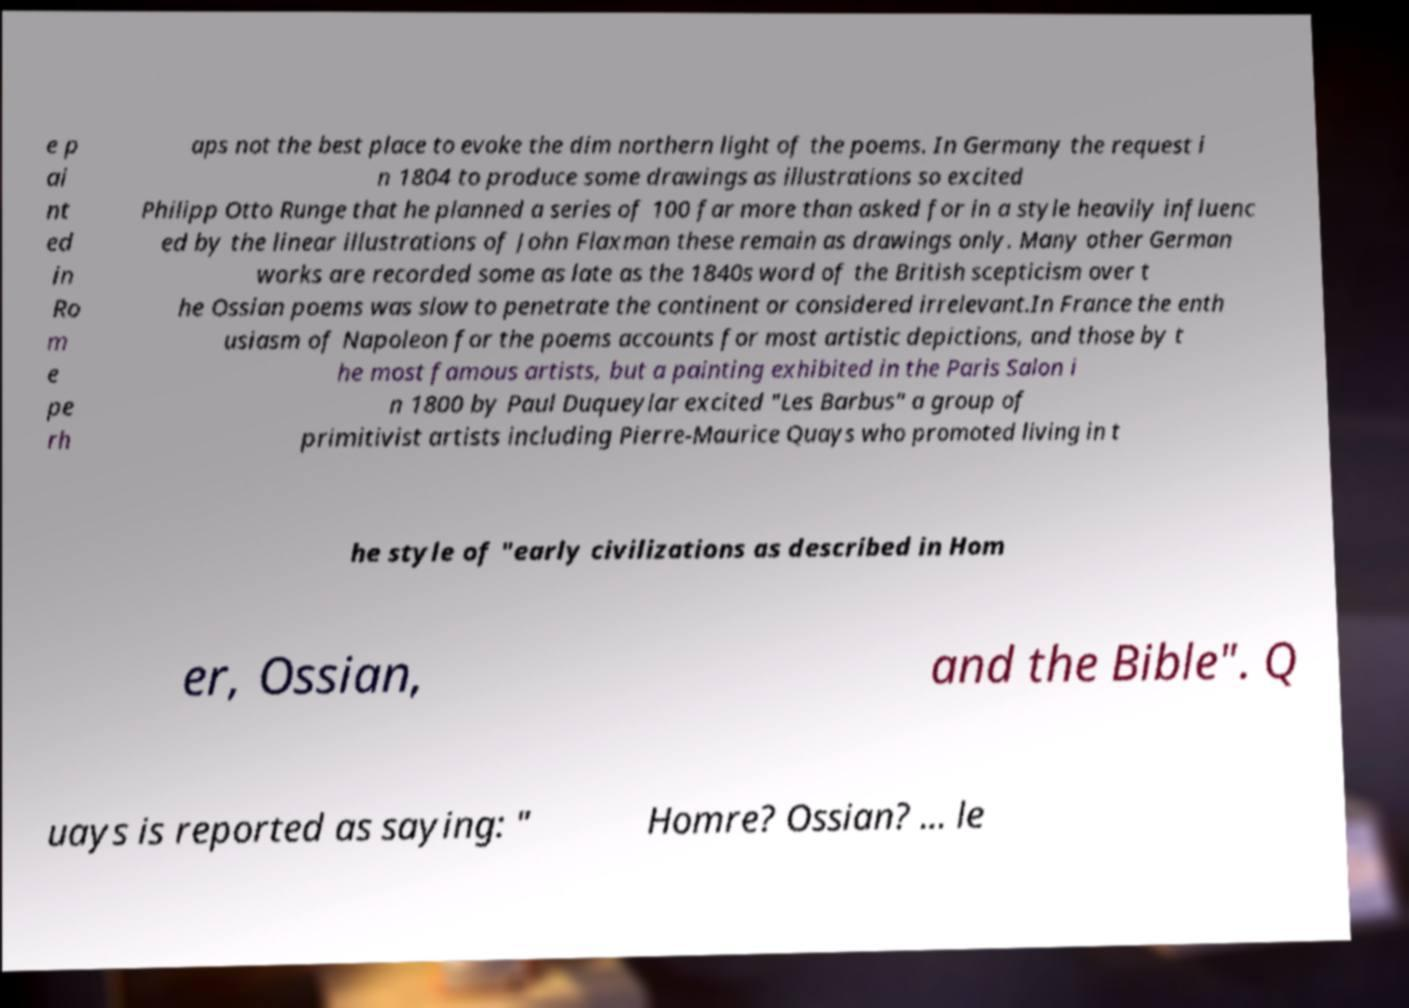Can you accurately transcribe the text from the provided image for me? e p ai nt ed in Ro m e pe rh aps not the best place to evoke the dim northern light of the poems. In Germany the request i n 1804 to produce some drawings as illustrations so excited Philipp Otto Runge that he planned a series of 100 far more than asked for in a style heavily influenc ed by the linear illustrations of John Flaxman these remain as drawings only. Many other German works are recorded some as late as the 1840s word of the British scepticism over t he Ossian poems was slow to penetrate the continent or considered irrelevant.In France the enth usiasm of Napoleon for the poems accounts for most artistic depictions, and those by t he most famous artists, but a painting exhibited in the Paris Salon i n 1800 by Paul Duqueylar excited "Les Barbus" a group of primitivist artists including Pierre-Maurice Quays who promoted living in t he style of "early civilizations as described in Hom er, Ossian, and the Bible". Q uays is reported as saying: " Homre? Ossian? ... le 